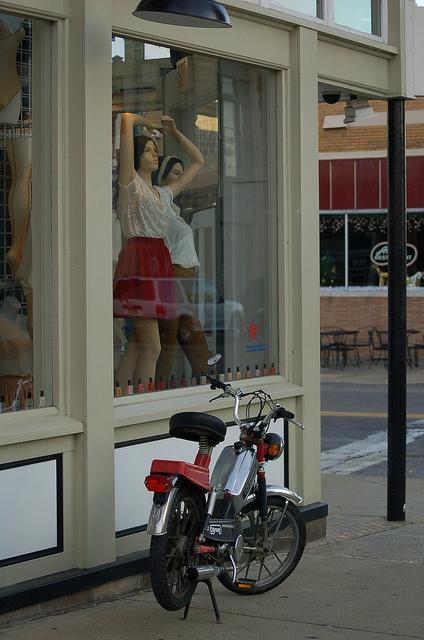How many people are there?
Give a very brief answer. 2. 